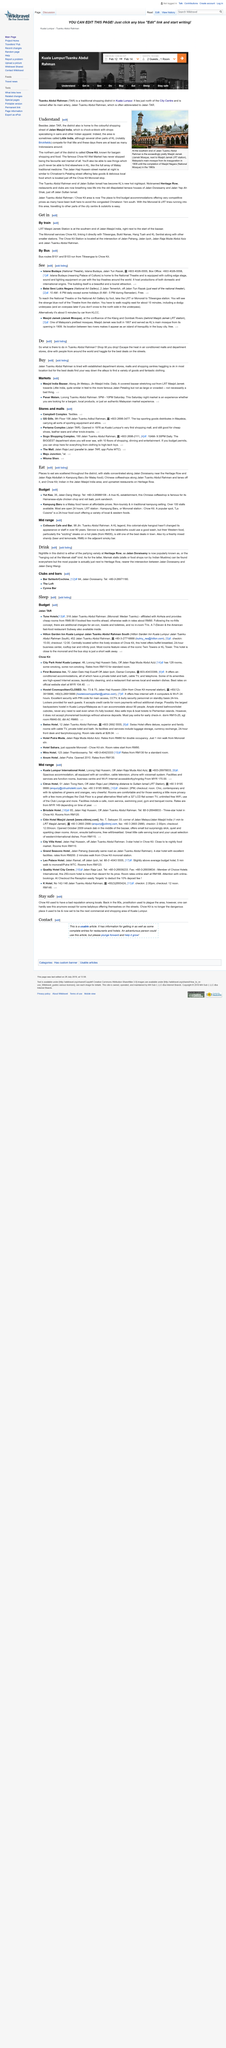Outline some significant characteristics in this image. Jalan Masjid India is not the favourite wet market of all. The Jalan Haji Hussein street market is similar to Chinatown's Petaling street at night, being a bustling and vibrant street market that attracts many visitors. Chow Kit is located in the district, and there is a question as to whether it is in the northern or southern part of the district. According to the speaker, it is in the northern part of the district. 